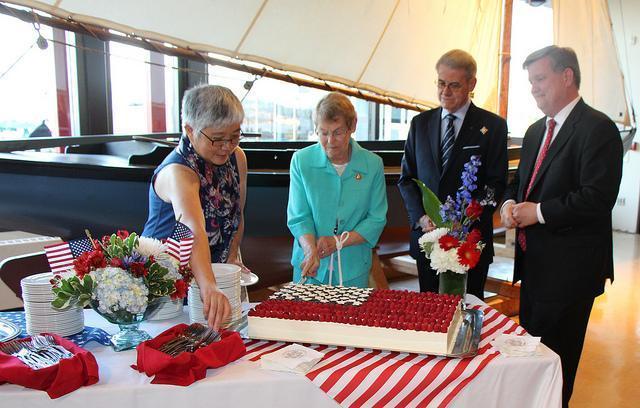How many people are visible?
Give a very brief answer. 4. 